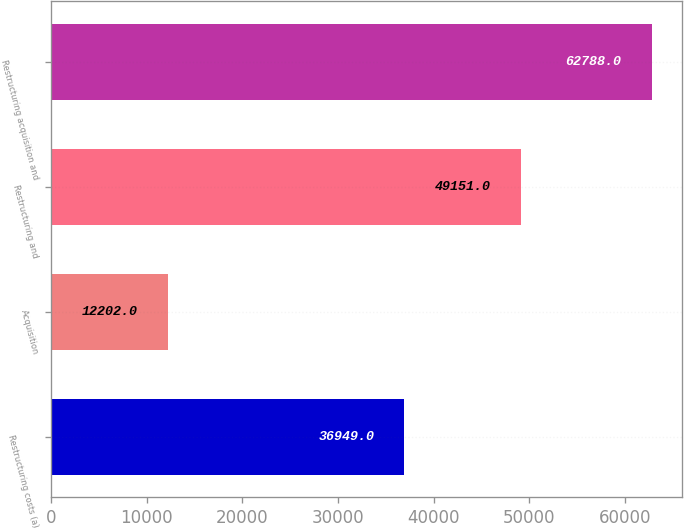<chart> <loc_0><loc_0><loc_500><loc_500><bar_chart><fcel>Restructuring costs (a)<fcel>Acquisition<fcel>Restructuring and<fcel>Restructuring acquisition and<nl><fcel>36949<fcel>12202<fcel>49151<fcel>62788<nl></chart> 